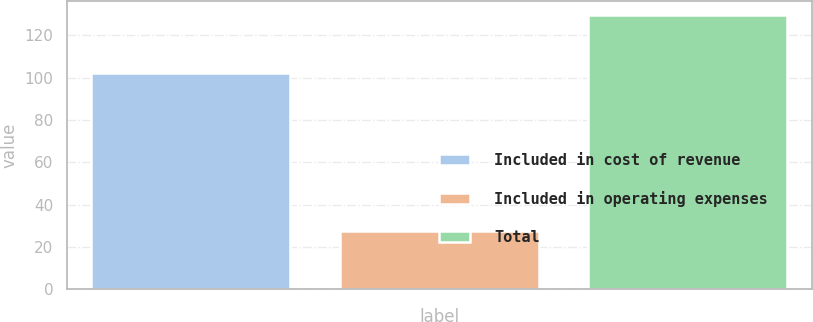Convert chart. <chart><loc_0><loc_0><loc_500><loc_500><bar_chart><fcel>Included in cost of revenue<fcel>Included in operating expenses<fcel>Total<nl><fcel>102.1<fcel>27.5<fcel>129.6<nl></chart> 